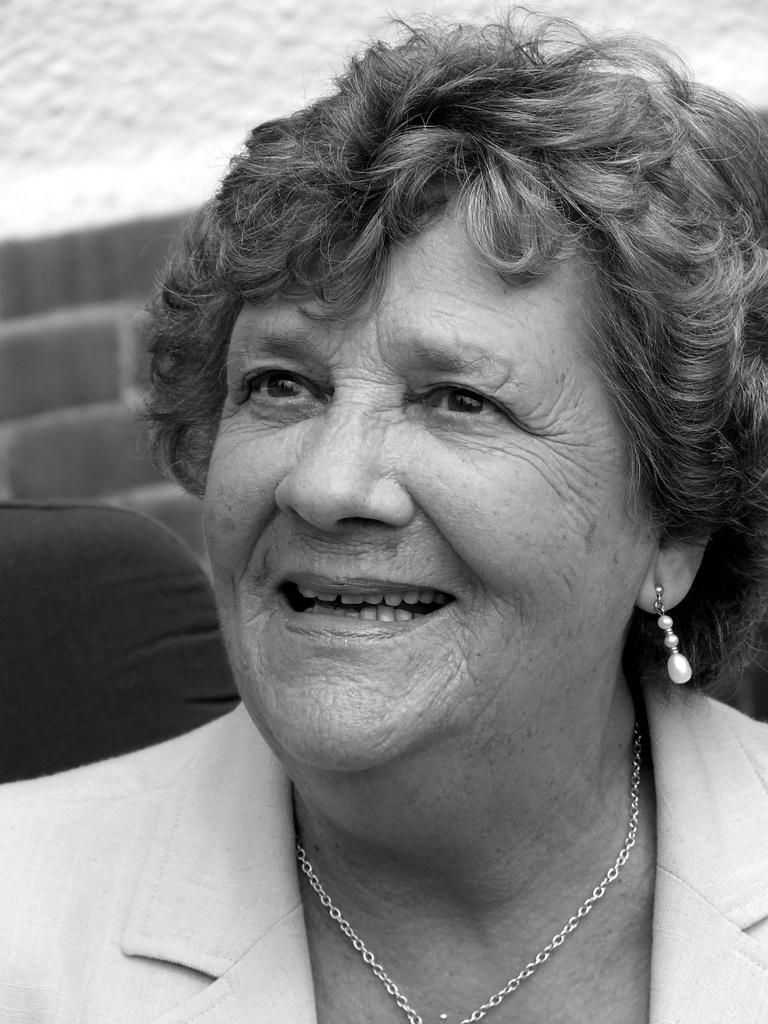Could you give a brief overview of what you see in this image? This is a black and white image where In the foreground of this picture, there is a woman in suit having smile on her face is sitting on a black chair. In the background, there is a wall. 